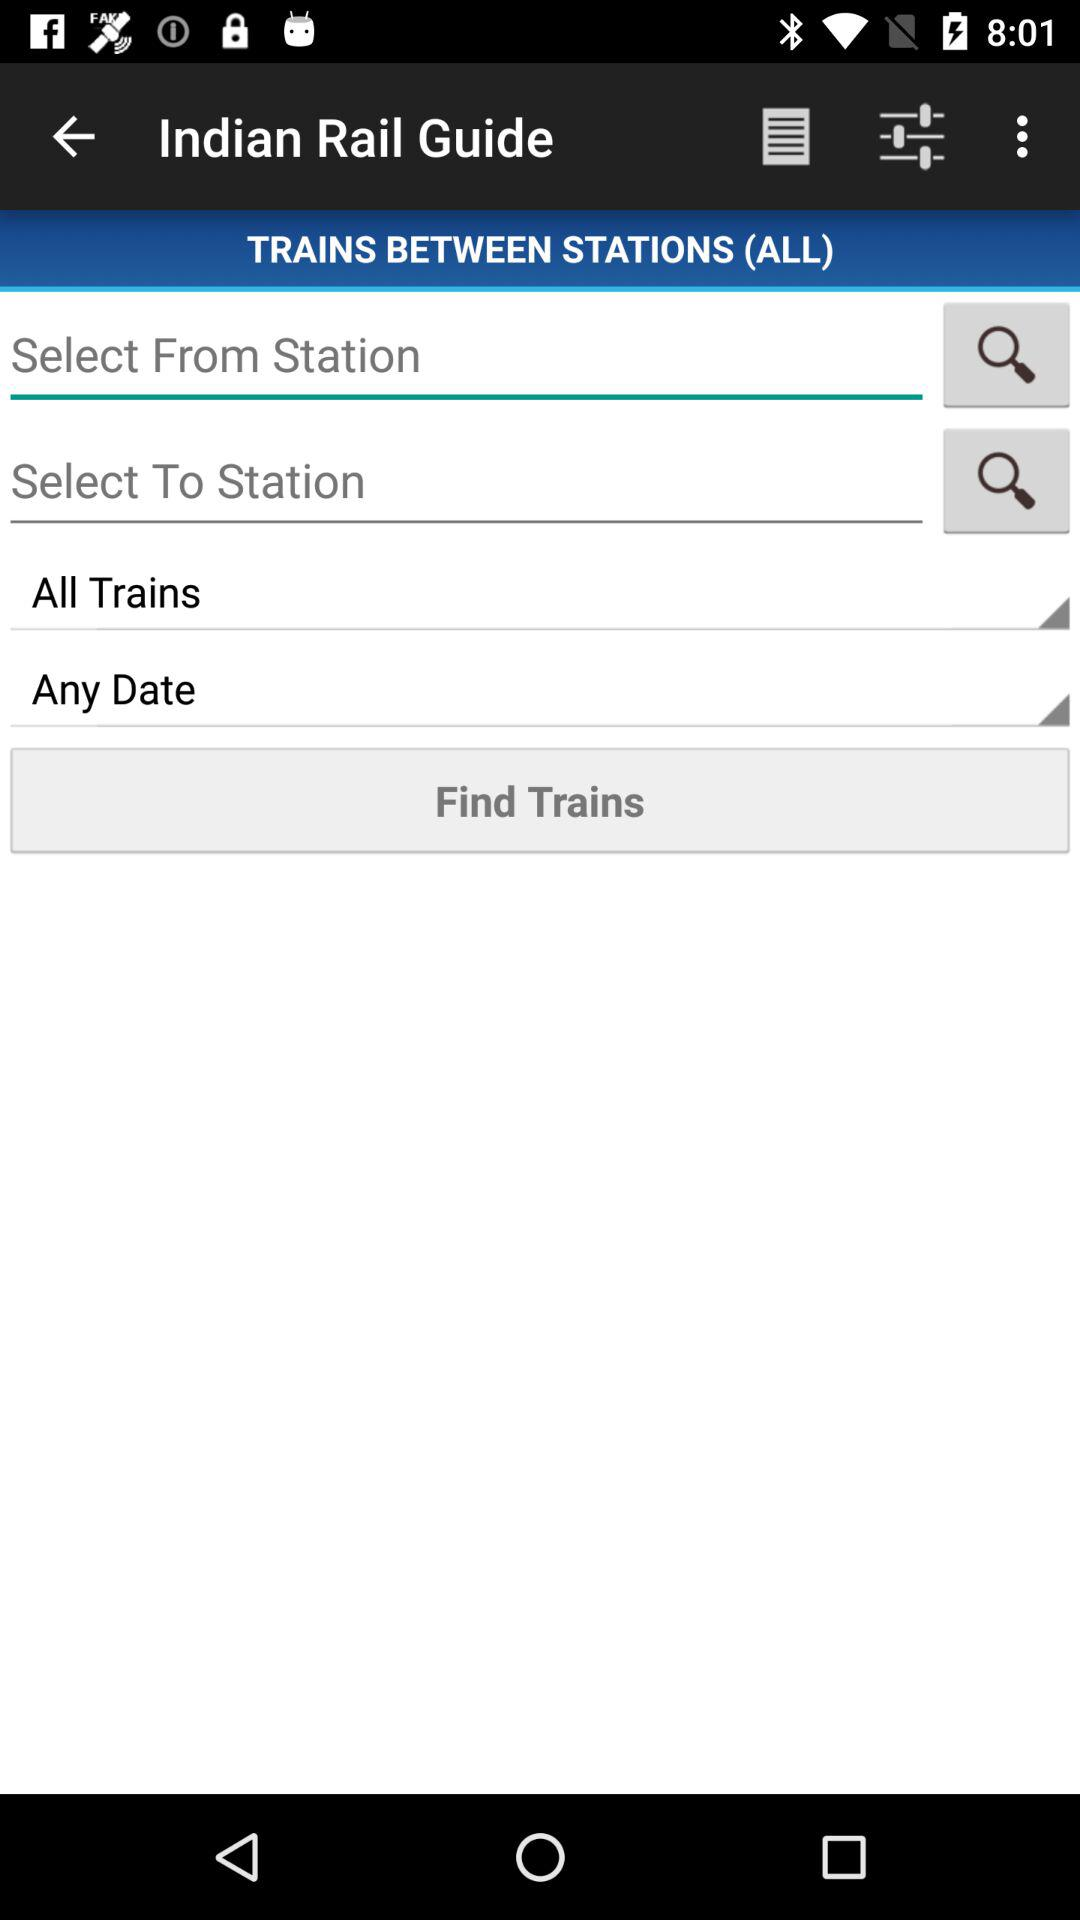How many more input fields are there for selecting a station than for selecting a date?
Answer the question using a single word or phrase. 1 